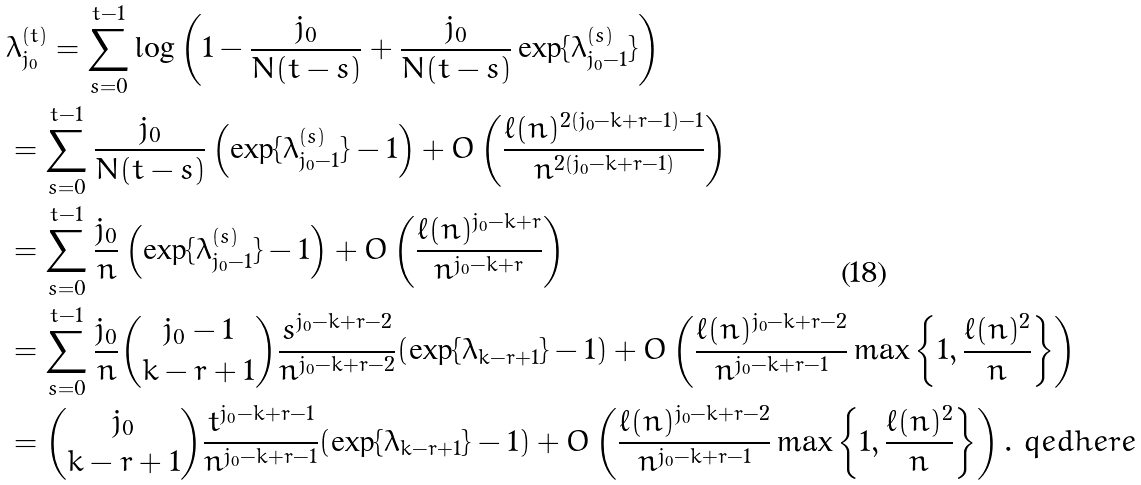Convert formula to latex. <formula><loc_0><loc_0><loc_500><loc_500>& \lambda _ { j _ { 0 } } ^ { ( t ) } = \sum _ { s = 0 } ^ { t - 1 } \log \left ( 1 - \frac { j _ { 0 } } { N ( t - s ) } + \frac { j _ { 0 } } { N ( t - s ) } \exp \{ \lambda _ { j _ { 0 } - 1 } ^ { ( s ) } \} \right ) \\ & = \sum _ { s = 0 } ^ { t - 1 } \frac { j _ { 0 } } { N ( t - s ) } \left ( \exp \{ \lambda _ { j _ { 0 } - 1 } ^ { ( s ) } \} - 1 \right ) + O \left ( \frac { \ell ( n ) ^ { 2 ( j _ { 0 } - k + r - 1 ) - 1 } } { n ^ { 2 ( j _ { 0 } - k + r - 1 ) } } \right ) \\ & = \sum _ { s = 0 } ^ { t - 1 } \frac { j _ { 0 } } { n } \left ( \exp \{ \lambda _ { j _ { 0 } - 1 } ^ { ( s ) } \} - 1 \right ) + O \left ( \frac { \ell ( n ) ^ { j _ { 0 } - k + r } } { n ^ { j _ { 0 } - k + r } } \right ) \\ & = \sum _ { s = 0 } ^ { t - 1 } \frac { j _ { 0 } } { n } \binom { j _ { 0 } - 1 } { k - r + 1 } \frac { s ^ { j _ { 0 } - k + r - 2 } } { n ^ { j _ { 0 } - k + r - 2 } } ( \exp \{ \lambda _ { k - r + 1 } \} - 1 ) + O \left ( \frac { \ell ( n ) ^ { j _ { 0 } - k + r - 2 } } { n ^ { j _ { 0 } - k + r - 1 } } \max \left \{ 1 , \frac { \ell ( n ) ^ { 2 } } { n } \right \} \right ) \\ & = \binom { j _ { 0 } } { k - r + 1 } \frac { t ^ { j _ { 0 } - k + r - 1 } } { n ^ { j _ { 0 } - k + r - 1 } } ( \exp \{ \lambda _ { k - r + 1 } \} - 1 ) + O \left ( \frac { \ell ( n ) ^ { j _ { 0 } - k + r - 2 } } { n ^ { j _ { 0 } - k + r - 1 } } \max \left \{ 1 , \frac { \ell ( n ) ^ { 2 } } { n } \right \} \right ) . \ q e d h e r e</formula> 